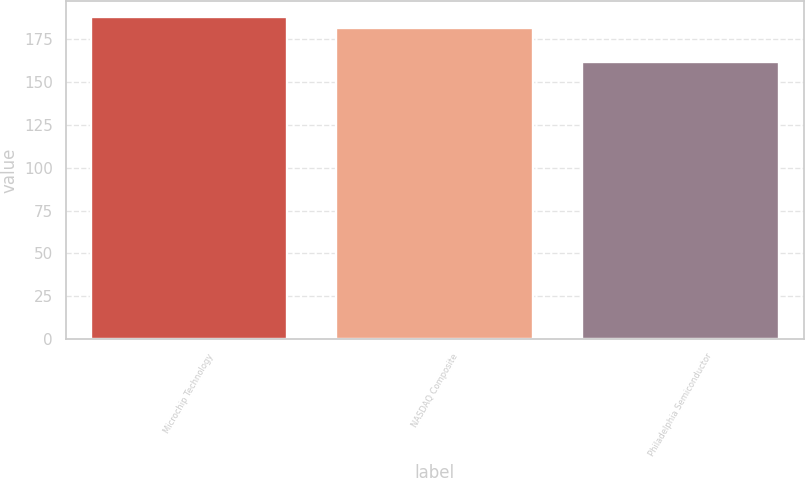Convert chart to OTSL. <chart><loc_0><loc_0><loc_500><loc_500><bar_chart><fcel>Microchip Technology<fcel>NASDAQ Composite<fcel>Philadelphia Semiconductor<nl><fcel>187.86<fcel>181.51<fcel>161.55<nl></chart> 